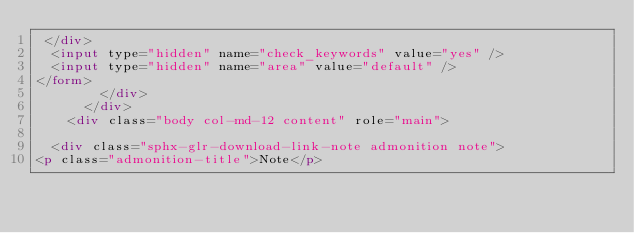<code> <loc_0><loc_0><loc_500><loc_500><_HTML_> </div>
  <input type="hidden" name="check_keywords" value="yes" />
  <input type="hidden" name="area" value="default" />
</form>
        </div>
      </div>
    <div class="body col-md-12 content" role="main">
      
  <div class="sphx-glr-download-link-note admonition note">
<p class="admonition-title">Note</p></code> 